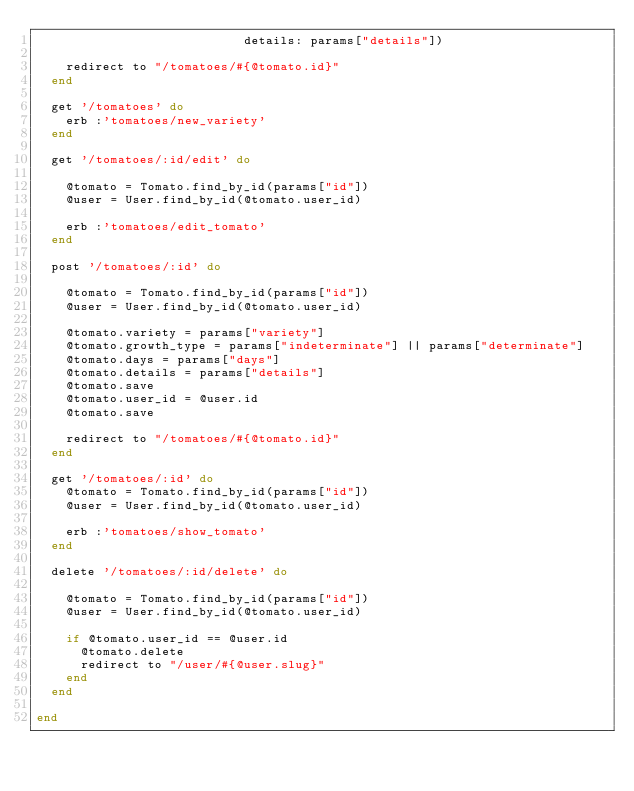Convert code to text. <code><loc_0><loc_0><loc_500><loc_500><_Ruby_>                            details: params["details"])

    redirect to "/tomatoes/#{@tomato.id}"
  end

  get '/tomatoes' do
    erb :'tomatoes/new_variety'
  end

  get '/tomatoes/:id/edit' do

    @tomato = Tomato.find_by_id(params["id"])
    @user = User.find_by_id(@tomato.user_id)

    erb :'tomatoes/edit_tomato'
  end

  post '/tomatoes/:id' do

    @tomato = Tomato.find_by_id(params["id"])
    @user = User.find_by_id(@tomato.user_id)

    @tomato.variety = params["variety"]
    @tomato.growth_type = params["indeterminate"] || params["determinate"]
    @tomato.days = params["days"]
    @tomato.details = params["details"]
    @tomato.save
    @tomato.user_id = @user.id
    @tomato.save

    redirect to "/tomatoes/#{@tomato.id}"
  end

  get '/tomatoes/:id' do
    @tomato = Tomato.find_by_id(params["id"])
    @user = User.find_by_id(@tomato.user_id)

    erb :'tomatoes/show_tomato'
  end

  delete '/tomatoes/:id/delete' do

    @tomato = Tomato.find_by_id(params["id"])
    @user = User.find_by_id(@tomato.user_id)

    if @tomato.user_id == @user.id
      @tomato.delete
      redirect to "/user/#{@user.slug}"
    end
  end

end
</code> 